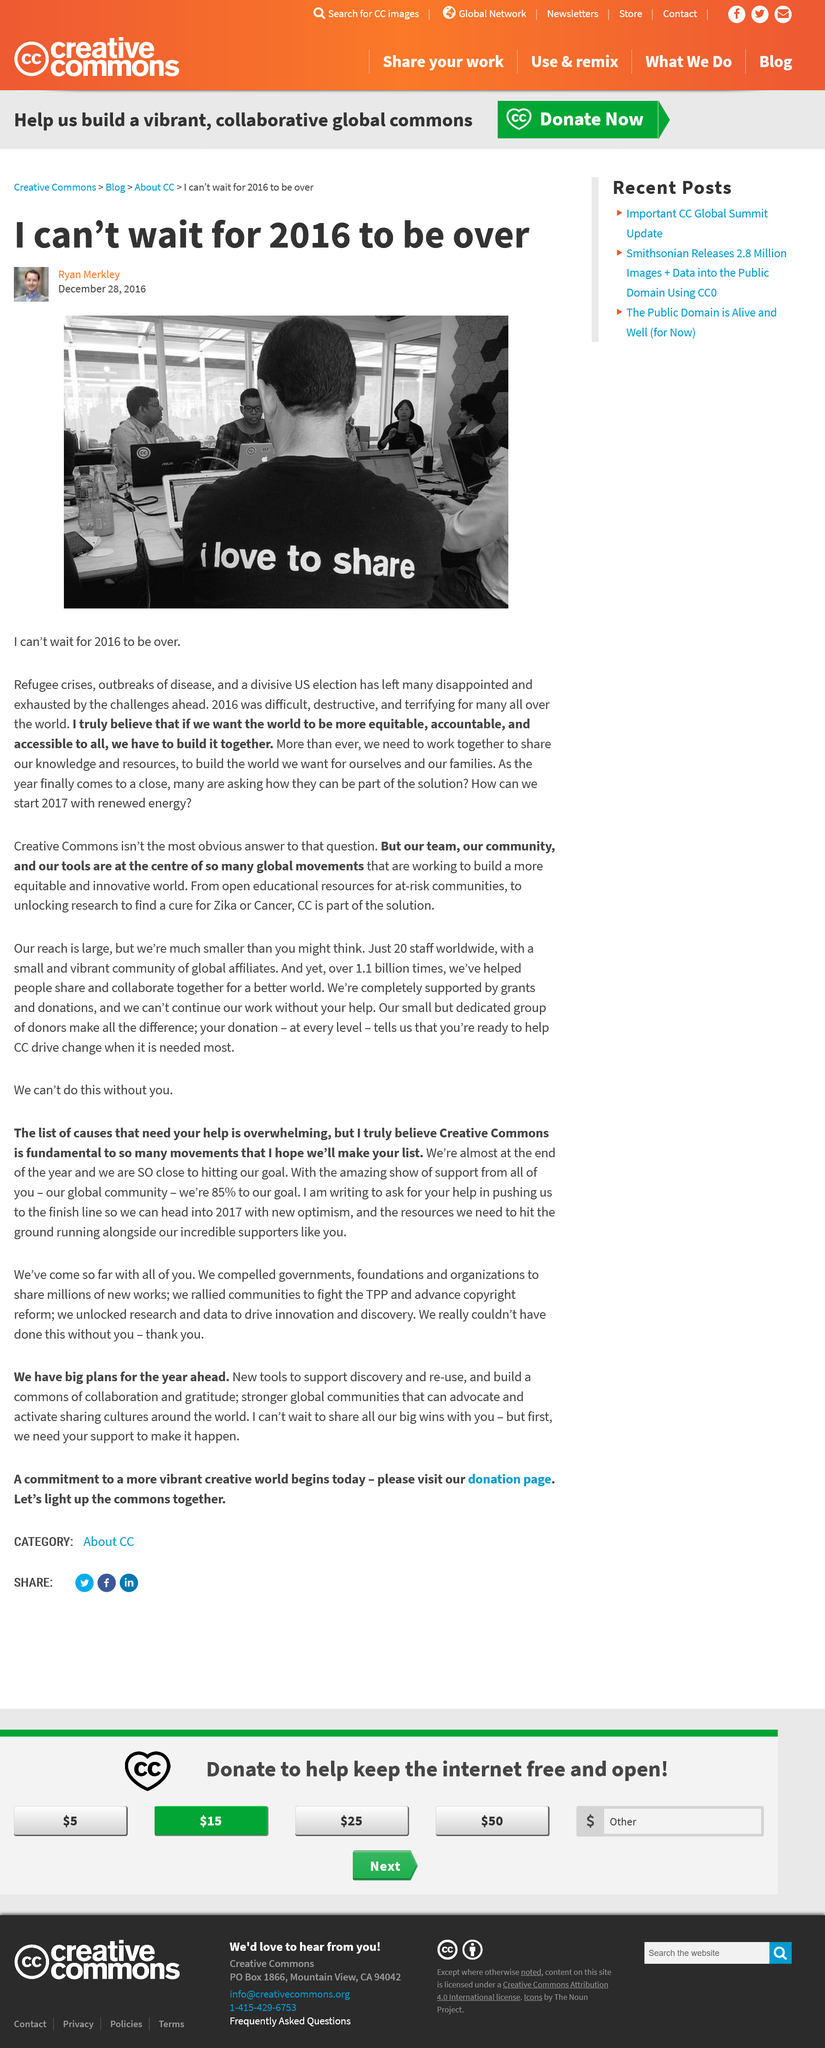Give some essential details in this illustration. After 2016, many people felt disappointed, exhausted, and terrified. Ryan desires for 2016 to conclude because that year was challenging because of the refugee crisis, outbreaks of illness, and the US presidential election. In 2016, a significant number of events unfolded that had a profound impact on global politics, health, and society. These events included the refugee crisis, outbreaks of disease, and a highly divisive US election. 